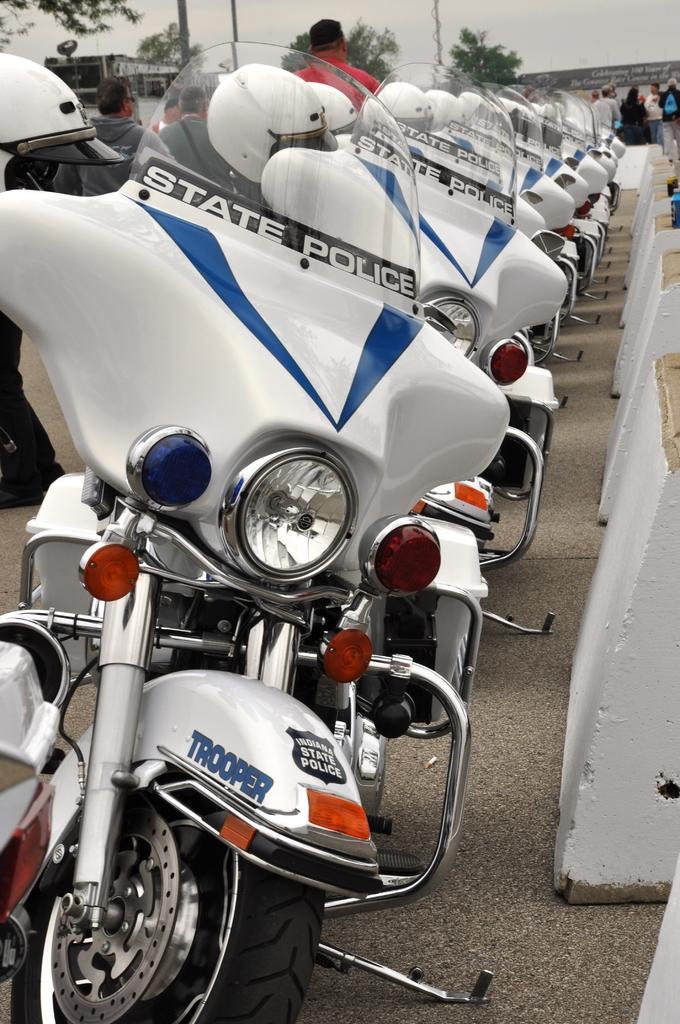Please provide a concise description of this image. In the picture we can see police bikes which are white in color are parked in one line and behind the bikes we can see some people are standing and in the background we can see some poles, trees and sky. 